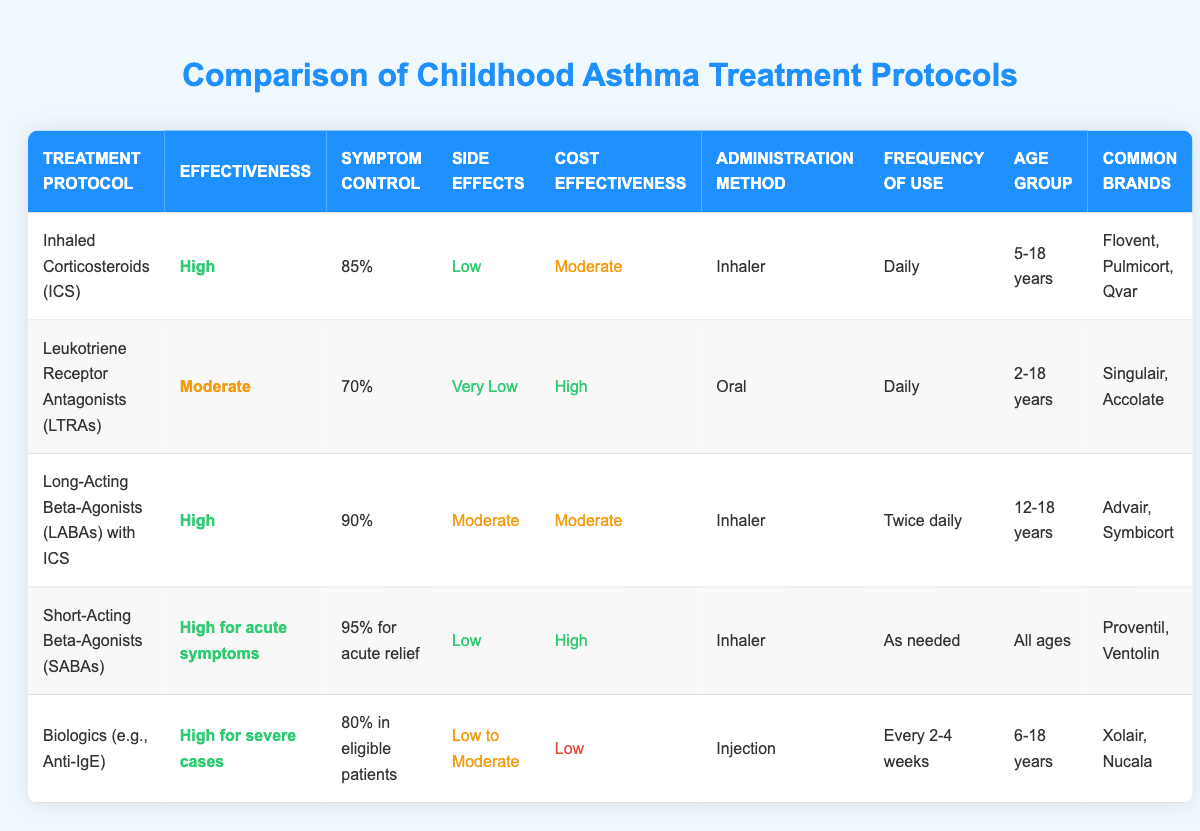What is the effectiveness of Inhaled Corticosteroids (ICS)? By looking at the table, we see that the effectiveness of Inhaled Corticosteroids (ICS) is categorized as "High."
Answer: High Which treatment protocol has the lowest reported side effects? The treatment protocol for Leukotriene Receptor Antagonists (LTRAs) reports "Very Low" side effects, which is lower than all other treatments in the table.
Answer: Leukotriene Receptor Antagonists (LTRAs) What is the symptom control percentage for Long-Acting Beta-Agonists (LABAs) with ICS? According to the table, Long-Acting Beta-Agonists (LABAs) with ICS have a symptom control percentage of 90%.
Answer: 90% Is the cost-effectiveness of Biologics considered high? In the table, the cost-effectiveness of Biologics is listed as "Low," therefore, it is not considered high.
Answer: No What is the average frequency of use for treatments that require daily administration? The treatments that require daily administration are Inhaled Corticosteroids (ICS) and Leukotriene Receptor Antagonists (LTRAs). Both are used daily, so the average frequency from these two entries is "Daily."
Answer: Daily How many treatment protocols can be administered via an inhaler? The table lists Inhaled Corticosteroids (ICS), Long-Acting Beta-Agonists (LABAs) with ICS, and Short-Acting Beta-Agonists (SABAs) as the protocols administered via an inhaler. This totals to three treatment protocols.
Answer: 3 Does the side effects level increase with the cost-effectiveness classification? By analyzing the side effects alongside the cost-effectiveness in the table, we see that even with moderate side effects (e.g., Long-Acting Beta-Agonists with ICS), it does not correlate with high cost-effectiveness. Therefore, we conclude there's no direct relationship here.
Answer: No What percentage of symptom control does Short-Acting Beta-Agonists (SABAs) offer for acute relief? The table indicates that Short-Acting Beta-Agonists (SABAs) provide a symptom control percentage of 95% for acute relief.
Answer: 95% What is the administration method for Leukotriene Receptor Antagonists (LTRAs)? From the table, we can see that the administration method for Leukotriene Receptor Antagonists (LTRAs) is "Oral."
Answer: Oral 